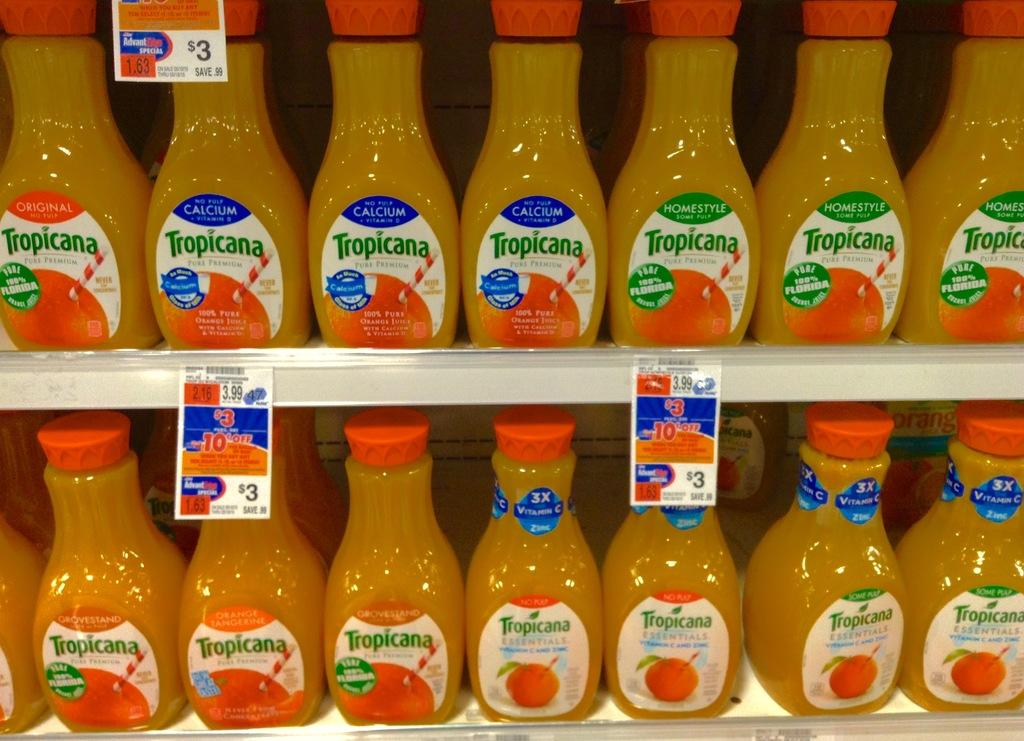<image>
Relay a brief, clear account of the picture shown. store shelves with tropicana orange juice in different varieties such as calcium, homestyle, no pulp, some pulp, and grovestand 